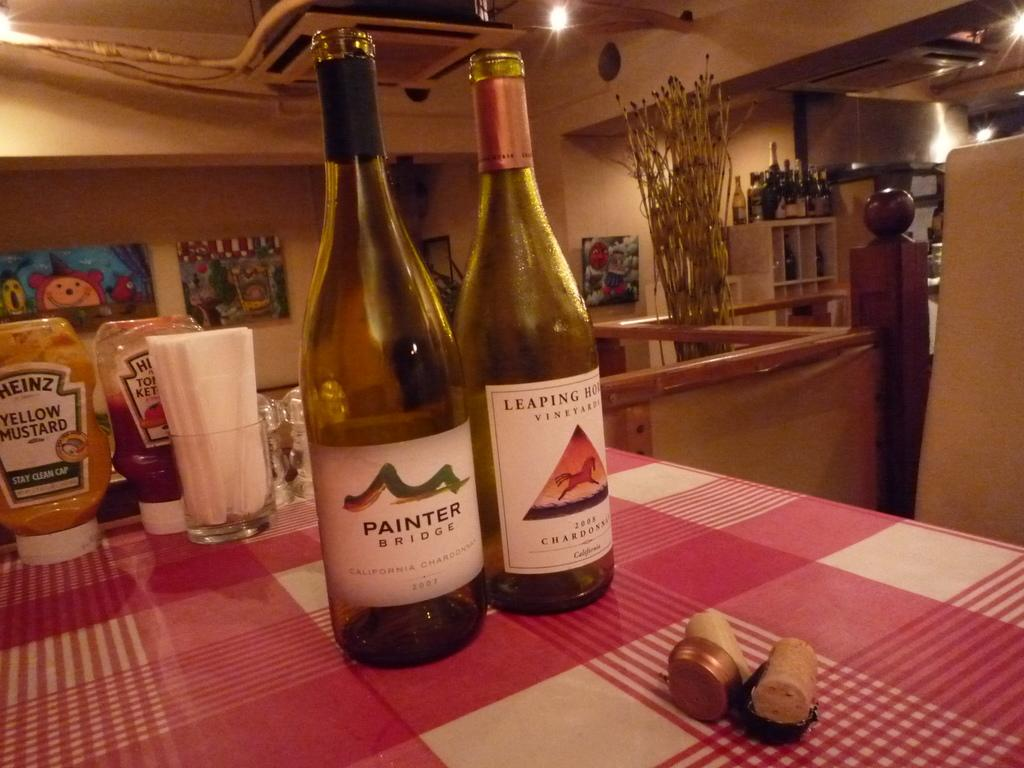Provide a one-sentence caption for the provided image. two bottles of white wine, opened, one of which is labelled painter. 